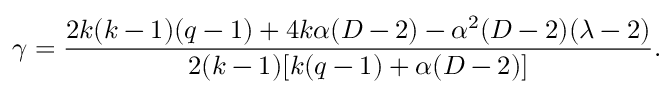Convert formula to latex. <formula><loc_0><loc_0><loc_500><loc_500>\gamma = \frac { 2 k ( k - 1 ) ( q - 1 ) + 4 k \alpha ( D - 2 ) - \alpha ^ { 2 } ( D - 2 ) ( \lambda - 2 ) } { 2 ( k - 1 ) [ k ( q - 1 ) + \alpha ( D - 2 ) ] } .</formula> 